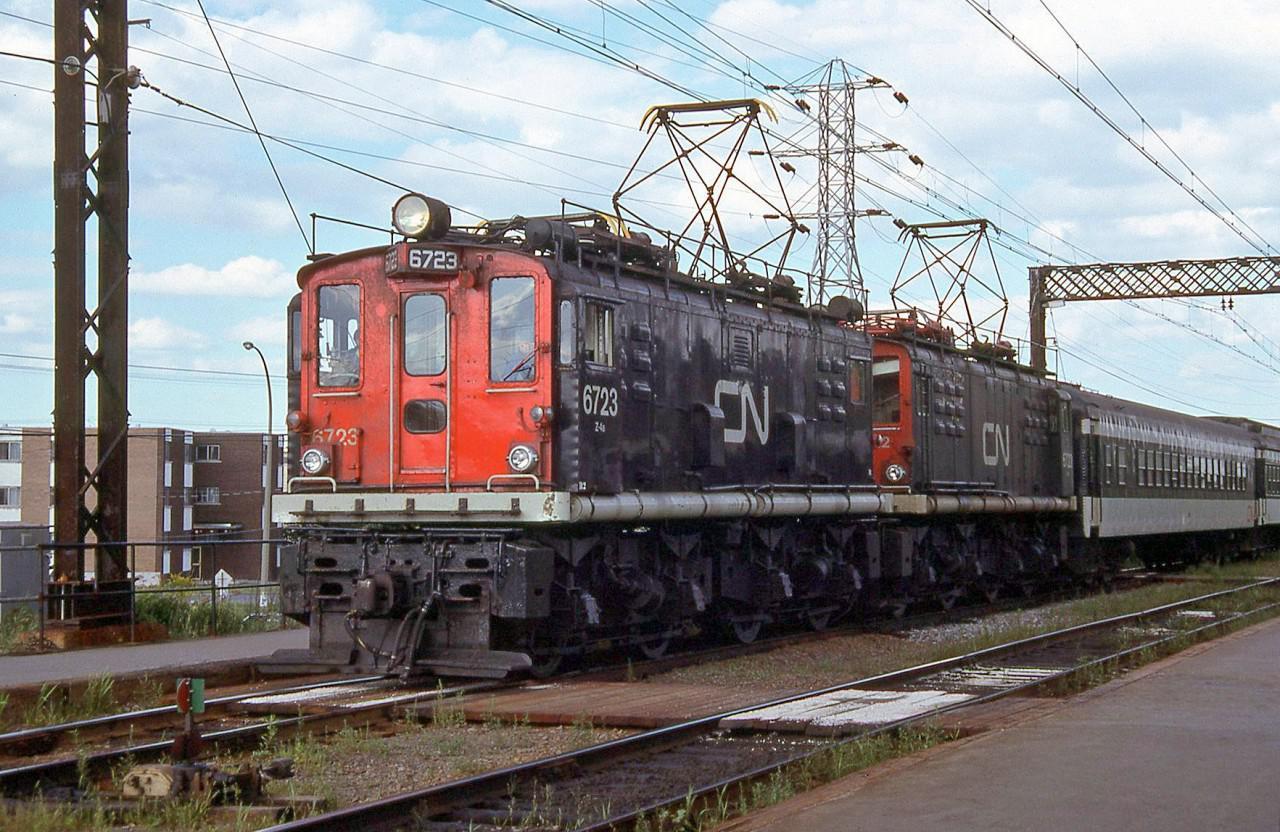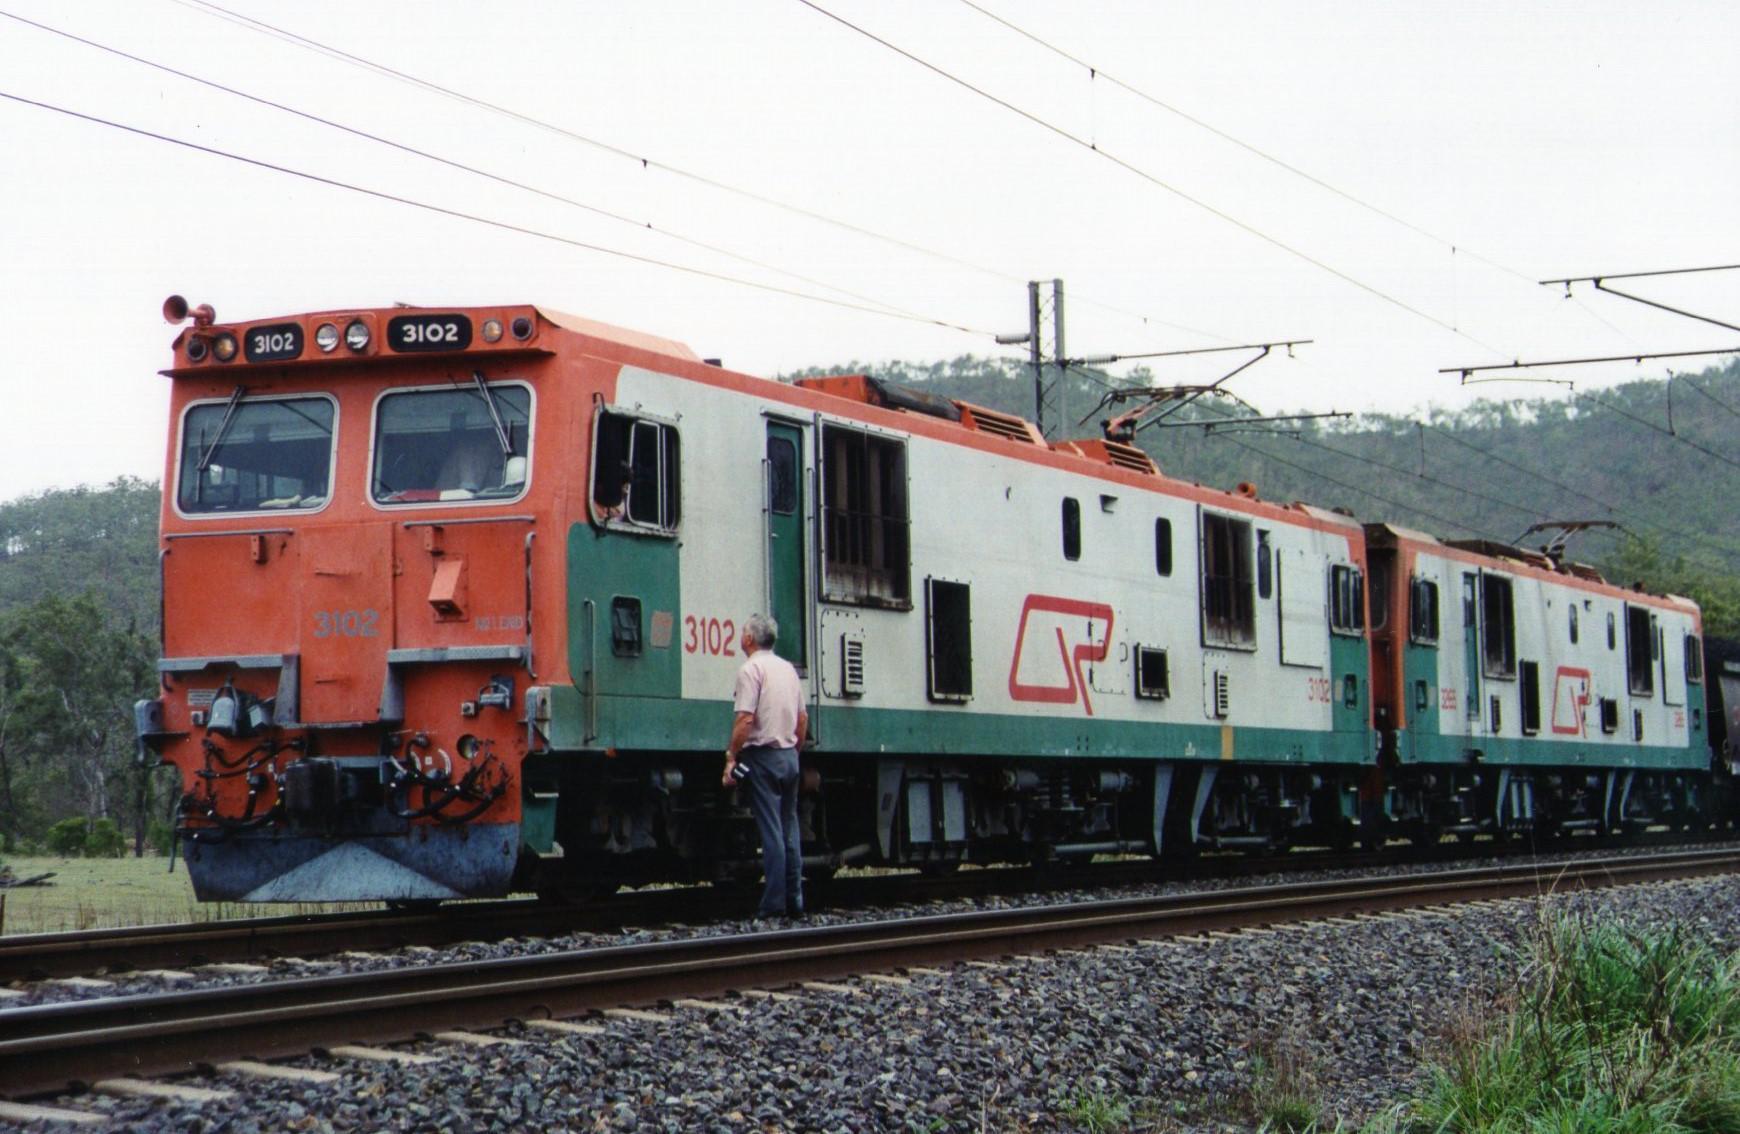The first image is the image on the left, the second image is the image on the right. Assess this claim about the two images: "Exactly two trains are angled in the same direction.". Correct or not? Answer yes or no. Yes. 